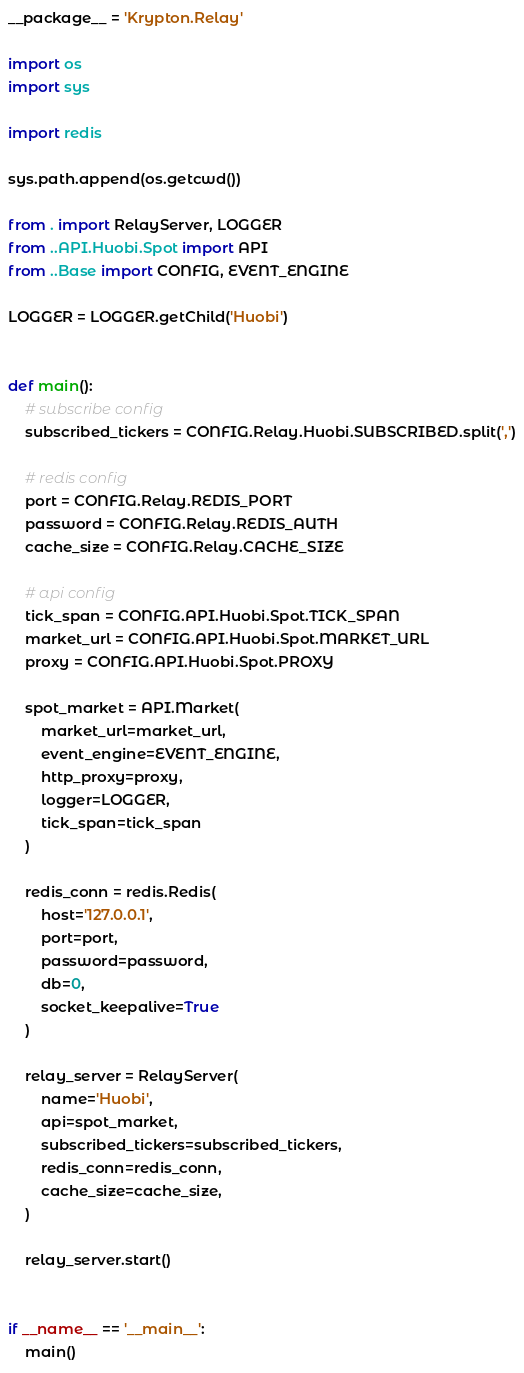Convert code to text. <code><loc_0><loc_0><loc_500><loc_500><_Python_>__package__ = 'Krypton.Relay'

import os
import sys

import redis

sys.path.append(os.getcwd())

from . import RelayServer, LOGGER
from ..API.Huobi.Spot import API
from ..Base import CONFIG, EVENT_ENGINE

LOGGER = LOGGER.getChild('Huobi')


def main():
    # subscribe config
    subscribed_tickers = CONFIG.Relay.Huobi.SUBSCRIBED.split(',')

    # redis config
    port = CONFIG.Relay.REDIS_PORT
    password = CONFIG.Relay.REDIS_AUTH
    cache_size = CONFIG.Relay.CACHE_SIZE

    # api config
    tick_span = CONFIG.API.Huobi.Spot.TICK_SPAN
    market_url = CONFIG.API.Huobi.Spot.MARKET_URL
    proxy = CONFIG.API.Huobi.Spot.PROXY

    spot_market = API.Market(
        market_url=market_url,
        event_engine=EVENT_ENGINE,
        http_proxy=proxy,
        logger=LOGGER,
        tick_span=tick_span
    )

    redis_conn = redis.Redis(
        host='127.0.0.1',
        port=port,
        password=password,
        db=0,
        socket_keepalive=True
    )

    relay_server = RelayServer(
        name='Huobi',
        api=spot_market,
        subscribed_tickers=subscribed_tickers,
        redis_conn=redis_conn,
        cache_size=cache_size,
    )

    relay_server.start()


if __name__ == '__main__':
    main()
</code> 